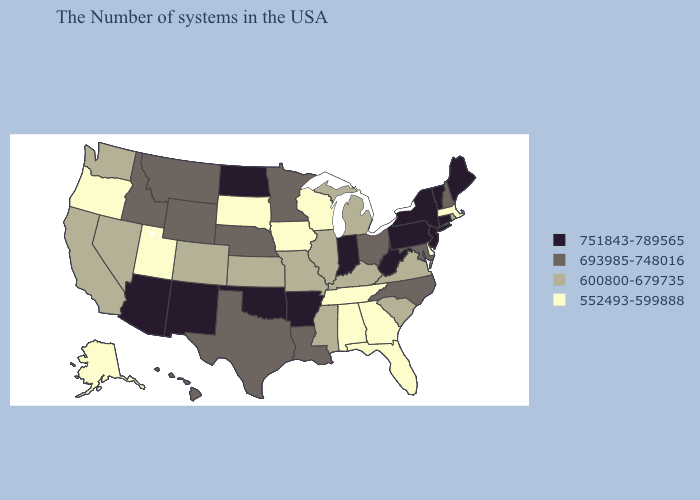Name the states that have a value in the range 751843-789565?
Short answer required. Maine, Vermont, Connecticut, New York, New Jersey, Pennsylvania, West Virginia, Indiana, Arkansas, Oklahoma, North Dakota, New Mexico, Arizona. Does Alabama have a higher value than South Dakota?
Be succinct. No. Does the map have missing data?
Answer briefly. No. Among the states that border Illinois , does Iowa have the highest value?
Give a very brief answer. No. What is the value of Alabama?
Short answer required. 552493-599888. What is the value of Montana?
Short answer required. 693985-748016. What is the lowest value in states that border Michigan?
Keep it brief. 552493-599888. What is the lowest value in the West?
Short answer required. 552493-599888. Name the states that have a value in the range 600800-679735?
Quick response, please. Rhode Island, Virginia, South Carolina, Michigan, Kentucky, Illinois, Mississippi, Missouri, Kansas, Colorado, Nevada, California, Washington. Among the states that border North Dakota , which have the lowest value?
Keep it brief. South Dakota. Which states have the lowest value in the South?
Be succinct. Delaware, Florida, Georgia, Alabama, Tennessee. Which states hav the highest value in the Northeast?
Answer briefly. Maine, Vermont, Connecticut, New York, New Jersey, Pennsylvania. What is the value of Arkansas?
Be succinct. 751843-789565. What is the value of Arizona?
Answer briefly. 751843-789565. 